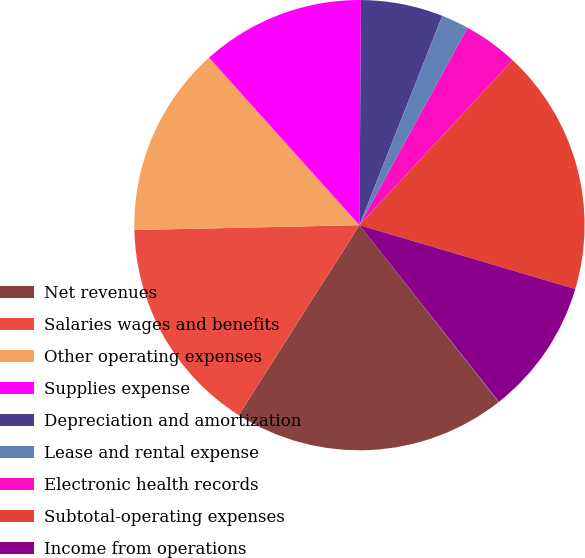<chart> <loc_0><loc_0><loc_500><loc_500><pie_chart><fcel>Net revenues<fcel>Salaries wages and benefits<fcel>Other operating expenses<fcel>Supplies expense<fcel>Depreciation and amortization<fcel>Lease and rental expense<fcel>Electronic health records<fcel>Subtotal-operating expenses<fcel>Income from operations<fcel>Interest expense net<nl><fcel>19.62%<fcel>15.65%<fcel>13.7%<fcel>11.75%<fcel>5.89%<fcel>1.98%<fcel>3.93%<fcel>17.67%<fcel>9.79%<fcel>0.02%<nl></chart> 